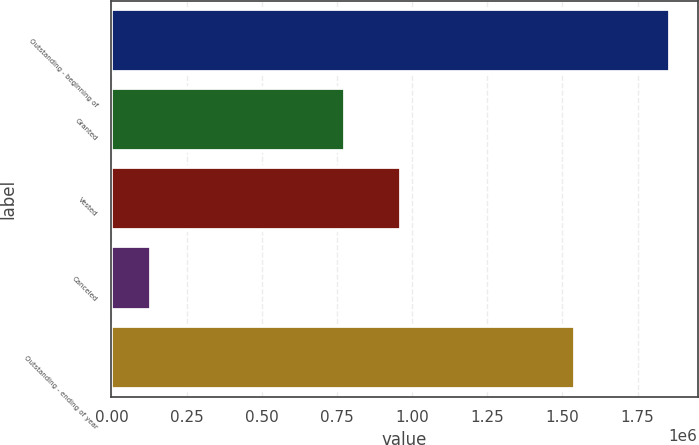Convert chart to OTSL. <chart><loc_0><loc_0><loc_500><loc_500><bar_chart><fcel>Outstanding - beginning of<fcel>Granted<fcel>Vested<fcel>Canceled<fcel>Outstanding - ending of year<nl><fcel>1.85655e+06<fcel>777730<fcel>962949<fcel>130486<fcel>1.54084e+06<nl></chart> 